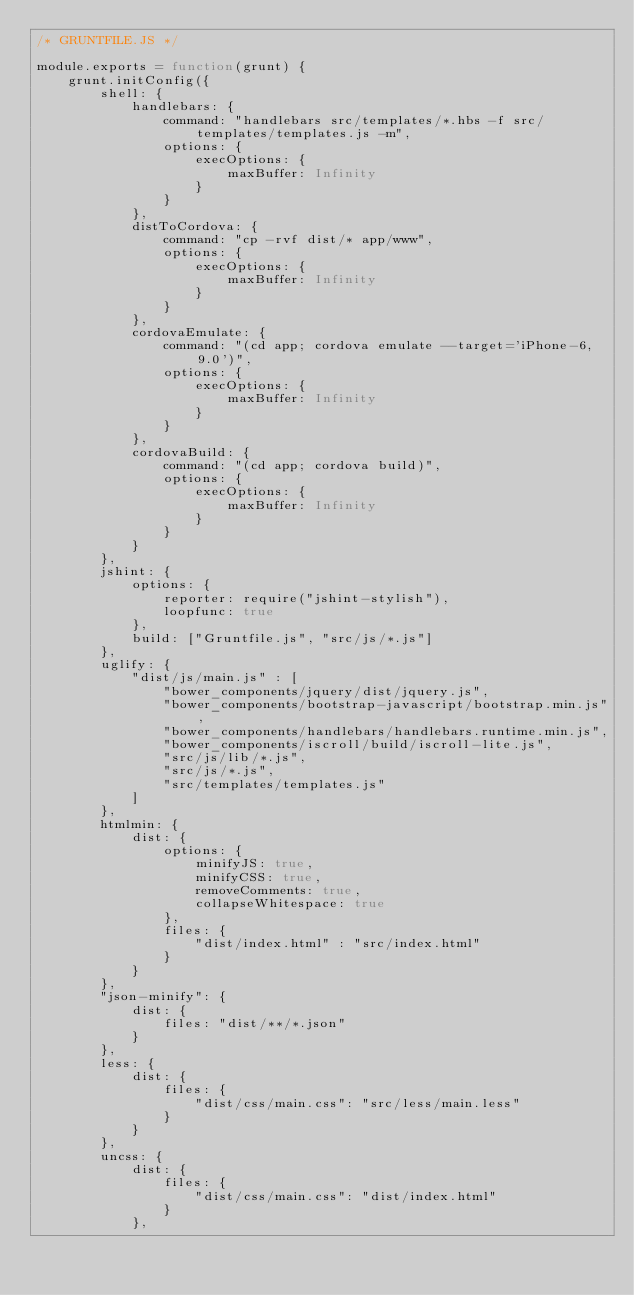Convert code to text. <code><loc_0><loc_0><loc_500><loc_500><_JavaScript_>/* GRUNTFILE.JS */

module.exports = function(grunt) {
	grunt.initConfig({
		shell: {
			handlebars: {
				command: "handlebars src/templates/*.hbs -f src/templates/templates.js -m",
	        	options: {
		            execOptions: {
		                maxBuffer: Infinity
		            }
		        }
        	},
        	distToCordova: {
				command: "cp -rvf dist/* app/www",
	        	options: {
		            execOptions: {
		                maxBuffer: Infinity
		            }
		        }
        	},
        	cordovaEmulate: {
				command: "(cd app; cordova emulate --target='iPhone-6, 9.0')",
	        	options: {
		            execOptions: {
		                maxBuffer: Infinity
		            }
		        }
        	},
        	cordovaBuild: {
				command: "(cd app; cordova build)",
	        	options: {
		            execOptions: {
		                maxBuffer: Infinity
		            }
		        }
        	}
		},
		jshint: {
			options: {
				reporter: require("jshint-stylish"),
				loopfunc: true
			},
			build: ["Gruntfile.js", "src/js/*.js"]
		},
		uglify: {
			"dist/js/main.js" : [
				"bower_components/jquery/dist/jquery.js",
				"bower_components/bootstrap-javascript/bootstrap.min.js",
				"bower_components/handlebars/handlebars.runtime.min.js",
				"bower_components/iscroll/build/iscroll-lite.js",
				"src/js/lib/*.js",
				"src/js/*.js",
				"src/templates/templates.js"
			]
		},
		htmlmin: {
			dist: {
				options: {
					minifyJS: true,
					minifyCSS: true,
					removeComments: true,
					collapseWhitespace: true
				},
				files: {
					"dist/index.html" : "src/index.html"
				}
			}
		},
		"json-minify": {
			dist: {
				files: "dist/**/*.json"
			}
		},
		less: {
			dist: {
				files: {
					"dist/css/main.css": "src/less/main.less"
				}
			}
		},
		uncss: {
			dist: {
				files: {
					"dist/css/main.css": "dist/index.html"
				}
			},</code> 